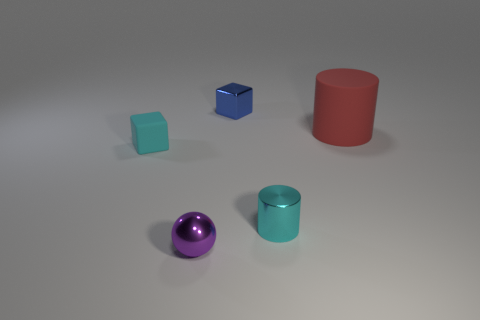Subtract all blue cubes. Subtract all gray spheres. How many cubes are left? 1 Add 3 large rubber cylinders. How many objects exist? 8 Subtract all cylinders. How many objects are left? 3 Subtract 0 yellow blocks. How many objects are left? 5 Subtract all tiny gray matte objects. Subtract all small cyan matte cubes. How many objects are left? 4 Add 3 small shiny things. How many small shiny things are left? 6 Add 1 small brown metal spheres. How many small brown metal spheres exist? 1 